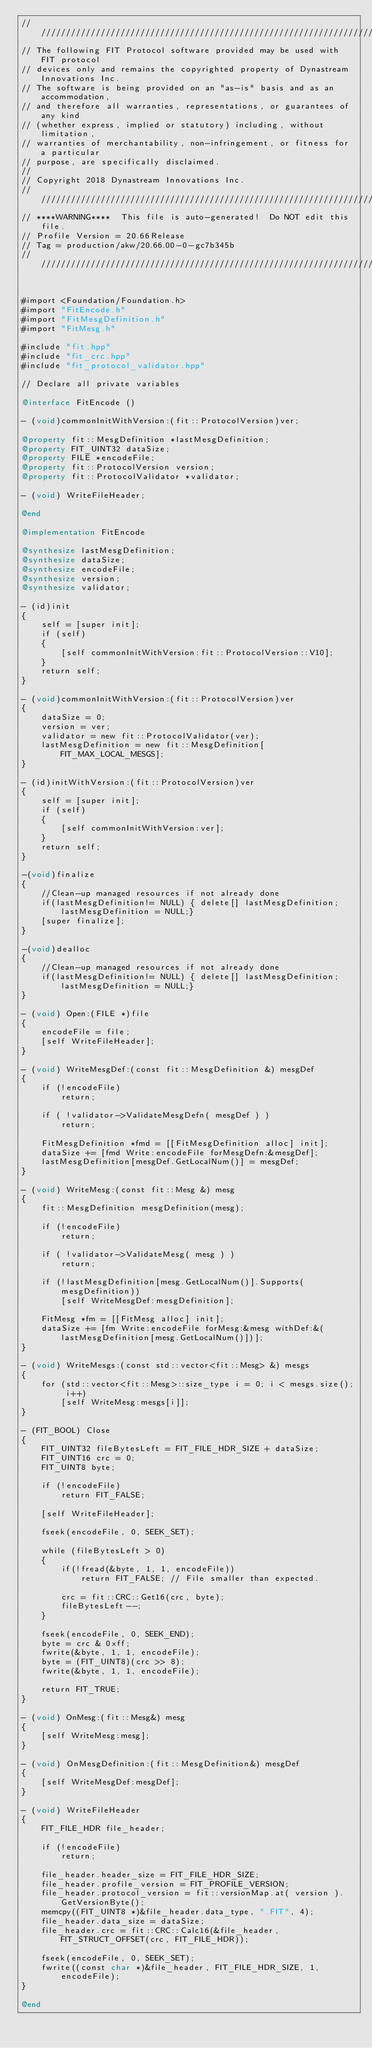<code> <loc_0><loc_0><loc_500><loc_500><_ObjectiveC_>////////////////////////////////////////////////////////////////////////////////
// The following FIT Protocol software provided may be used with FIT protocol
// devices only and remains the copyrighted property of Dynastream Innovations Inc.
// The software is being provided on an "as-is" basis and as an accommodation,
// and therefore all warranties, representations, or guarantees of any kind
// (whether express, implied or statutory) including, without limitation,
// warranties of merchantability, non-infringement, or fitness for a particular
// purpose, are specifically disclaimed.
//
// Copyright 2018 Dynastream Innovations Inc.
////////////////////////////////////////////////////////////////////////////////
// ****WARNING****  This file is auto-generated!  Do NOT edit this file.
// Profile Version = 20.66Release
// Tag = production/akw/20.66.00-0-gc7b345b
////////////////////////////////////////////////////////////////////////////////


#import <Foundation/Foundation.h>
#import "FitEncode.h"
#import "FitMesgDefinition.h"
#import "FitMesg.h"

#include "fit.hpp"
#include "fit_crc.hpp"
#include "fit_protocol_validator.hpp"

// Declare all private variables

@interface FitEncode ()

- (void)commonInitWithVersion:(fit::ProtocolVersion)ver;

@property fit::MesgDefinition *lastMesgDefinition;
@property FIT_UINT32 dataSize;
@property FILE *encodeFile;
@property fit::ProtocolVersion version;
@property fit::ProtocolValidator *validator;

- (void) WriteFileHeader;

@end

@implementation FitEncode

@synthesize lastMesgDefinition;
@synthesize dataSize;
@synthesize encodeFile;
@synthesize version;
@synthesize validator;

- (id)init
{
    self = [super init];
    if (self)
    {
        [self commonInitWithVersion:fit::ProtocolVersion::V10];
    }
    return self;
}

- (void)commonInitWithVersion:(fit::ProtocolVersion)ver
{
    dataSize = 0;
    version = ver;
    validator = new fit::ProtocolValidator(ver);
    lastMesgDefinition = new fit::MesgDefinition[FIT_MAX_LOCAL_MESGS];
}

- (id)initWithVersion:(fit::ProtocolVersion)ver
{
    self = [super init];
    if (self)
    {
        [self commonInitWithVersion:ver];
    }
    return self;
}

-(void)finalize
{
    //Clean-up managed resources if not already done
    if(lastMesgDefinition!= NULL) { delete[] lastMesgDefinition; lastMesgDefinition = NULL;}
    [super finalize];
}

-(void)dealloc
{
    //Clean-up managed resources if not already done
    if(lastMesgDefinition!= NULL) { delete[] lastMesgDefinition; lastMesgDefinition = NULL;}
}

- (void) Open:(FILE *)file
{
    encodeFile = file;
    [self WriteFileHeader];
}

- (void) WriteMesgDef:(const fit::MesgDefinition &) mesgDef
{
    if (!encodeFile)
        return;

    if ( !validator->ValidateMesgDefn( mesgDef ) )
        return;

    FitMesgDefinition *fmd = [[FitMesgDefinition alloc] init];
    dataSize += [fmd Write:encodeFile forMesgDefn:&mesgDef];
    lastMesgDefinition[mesgDef.GetLocalNum()] = mesgDef;
}

- (void) WriteMesg:(const fit::Mesg &) mesg
{
    fit::MesgDefinition mesgDefinition(mesg);

    if (!encodeFile)
        return;

    if ( !validator->ValidateMesg( mesg ) )
        return;

    if (!lastMesgDefinition[mesg.GetLocalNum()].Supports(mesgDefinition))
        [self WriteMesgDef:mesgDefinition];

    FitMesg *fm = [[FitMesg alloc] init];
    dataSize += [fm Write:encodeFile forMesg:&mesg withDef:&(lastMesgDefinition[mesg.GetLocalNum()])];
}

- (void) WriteMesgs:(const std::vector<fit::Mesg> &) mesgs
{
    for (std::vector<fit::Mesg>::size_type i = 0; i < mesgs.size(); i++)
        [self WriteMesg:mesgs[i]];
}

- (FIT_BOOL) Close
{
    FIT_UINT32 fileBytesLeft = FIT_FILE_HDR_SIZE + dataSize;
    FIT_UINT16 crc = 0;
    FIT_UINT8 byte;

    if (!encodeFile)
        return FIT_FALSE;

    [self WriteFileHeader];

    fseek(encodeFile, 0, SEEK_SET);

    while (fileBytesLeft > 0)
    {
        if(!fread(&byte, 1, 1, encodeFile))
            return FIT_FALSE; // File smaller than expected.

        crc = fit::CRC::Get16(crc, byte);
        fileBytesLeft--;
    }

    fseek(encodeFile, 0, SEEK_END);
    byte = crc & 0xff;
    fwrite(&byte, 1, 1, encodeFile);
    byte = (FIT_UINT8)(crc >> 8);
    fwrite(&byte, 1, 1, encodeFile);

    return FIT_TRUE;
}

- (void) OnMesg:(fit::Mesg&) mesg
{
    [self WriteMesg:mesg];
}

- (void) OnMesgDefinition:(fit::MesgDefinition&) mesgDef
{
    [self WriteMesgDef:mesgDef];
}

- (void) WriteFileHeader
{
    FIT_FILE_HDR file_header;

    if (!encodeFile)
        return;

    file_header.header_size = FIT_FILE_HDR_SIZE;
    file_header.profile_version = FIT_PROFILE_VERSION;
    file_header.protocol_version = fit::versionMap.at( version ).GetVersionByte();
    memcpy((FIT_UINT8 *)&file_header.data_type, ".FIT", 4);
    file_header.data_size = dataSize;
    file_header.crc = fit::CRC::Calc16(&file_header, FIT_STRUCT_OFFSET(crc, FIT_FILE_HDR));

    fseek(encodeFile, 0, SEEK_SET);
    fwrite((const char *)&file_header, FIT_FILE_HDR_SIZE, 1, encodeFile);
}

@end
</code> 